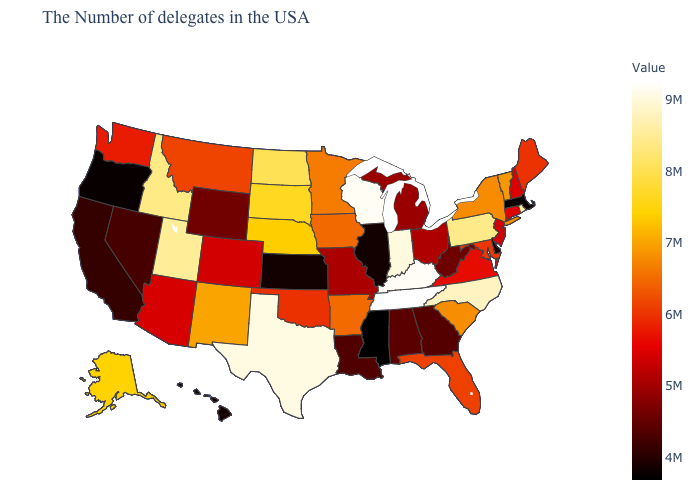Does the map have missing data?
Give a very brief answer. No. Which states have the lowest value in the South?
Be succinct. Mississippi. Which states hav the highest value in the Northeast?
Concise answer only. Rhode Island. Does Louisiana have the lowest value in the South?
Concise answer only. No. Which states have the lowest value in the South?
Quick response, please. Mississippi. Among the states that border Utah , which have the lowest value?
Short answer required. Nevada. Does New Jersey have the highest value in the Northeast?
Quick response, please. No. Does the map have missing data?
Give a very brief answer. No. 